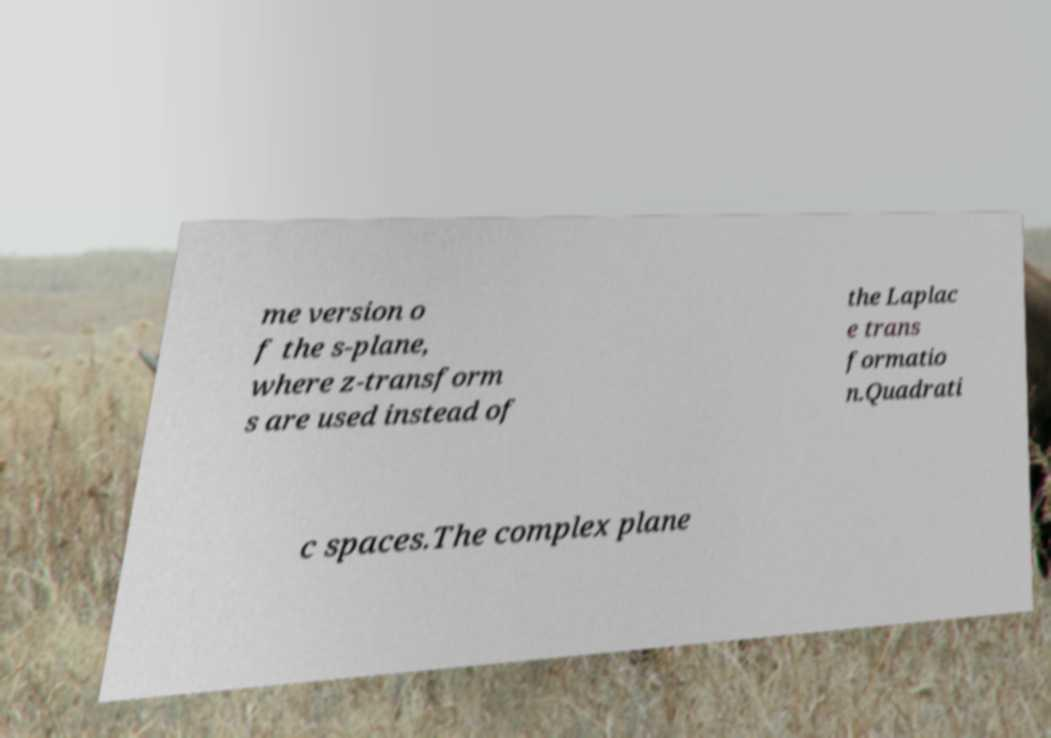Can you read and provide the text displayed in the image?This photo seems to have some interesting text. Can you extract and type it out for me? me version o f the s-plane, where z-transform s are used instead of the Laplac e trans formatio n.Quadrati c spaces.The complex plane 